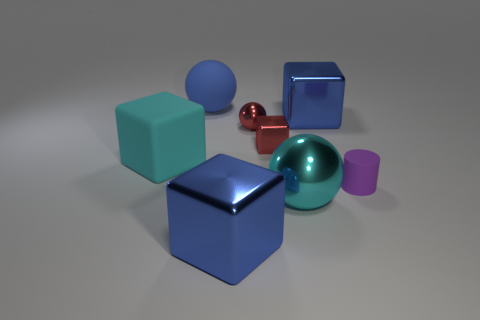Are there any reflective surfaces in the scene? Yes, the red sphere and both blue cubes exhibit reflective properties indicative of a metallic or glossy surface. 